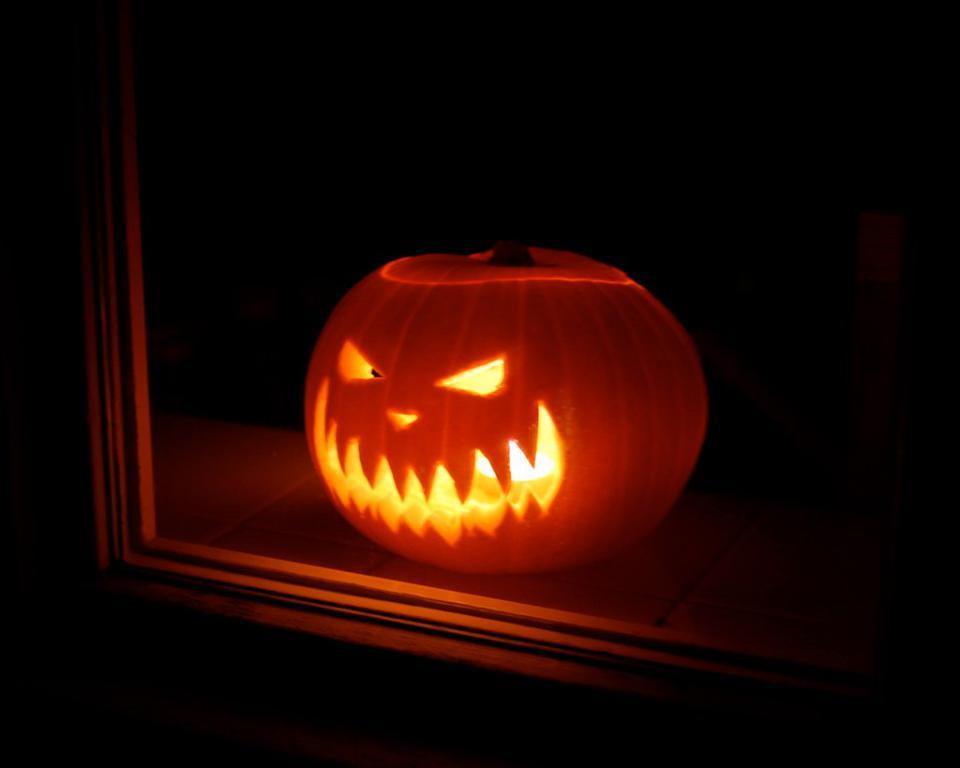What is the main subject of the image? There is a Halloween pumpkin in the image. What is inside the pumpkin? There is a light source inside the pumpkin. Can you describe the reflection in the image? The image of the pumpkin is reflected in a mirror. What type of property is being sold in the image? There is no property being sold in the image; it features a Halloween pumpkin with a light source and a mirror reflection. What role does celery play in the image? There is no celery present in the image. 